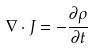<formula> <loc_0><loc_0><loc_500><loc_500>\nabla \cdot J = - \frac { \partial \rho } { \partial t }</formula> 